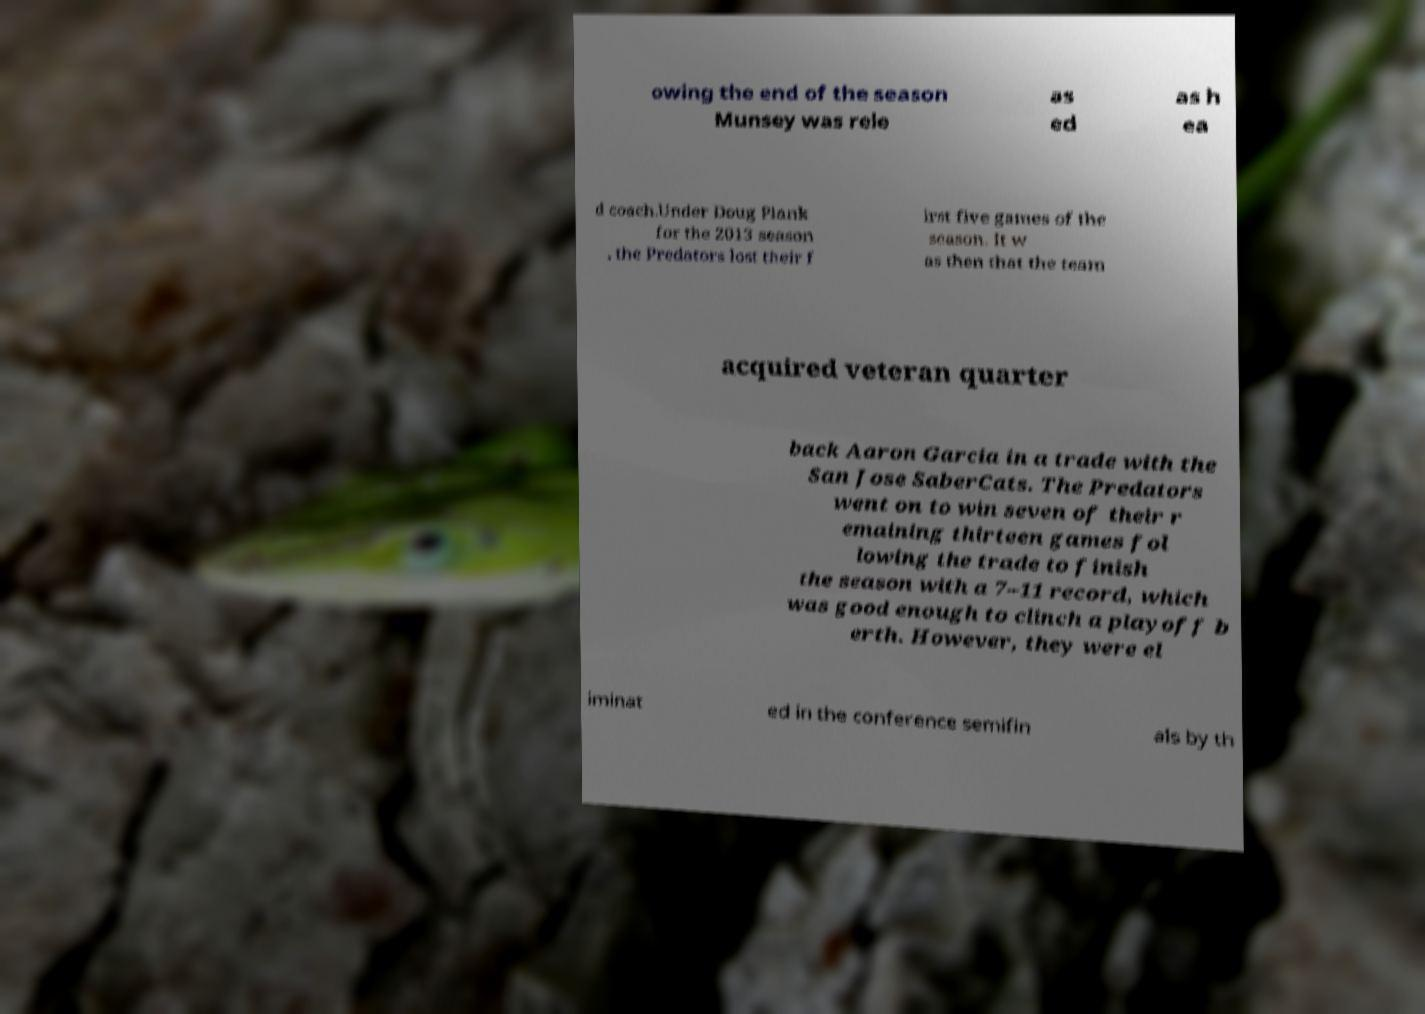Please read and relay the text visible in this image. What does it say? owing the end of the season Munsey was rele as ed as h ea d coach.Under Doug Plank for the 2013 season , the Predators lost their f irst five games of the season. It w as then that the team acquired veteran quarter back Aaron Garcia in a trade with the San Jose SaberCats. The Predators went on to win seven of their r emaining thirteen games fol lowing the trade to finish the season with a 7–11 record, which was good enough to clinch a playoff b erth. However, they were el iminat ed in the conference semifin als by th 